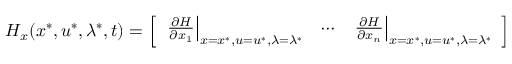<formula> <loc_0><loc_0><loc_500><loc_500>H _ { x } ( x ^ { * } , u ^ { * } , \lambda ^ { * } , t ) = { \left [ \begin{array} { l l l } { { \frac { \partial H } { \partial x _ { 1 } } } \right | _ { x = x ^ { * } , u = u ^ { * } , \lambda = \lambda ^ { * } } } & { \cdots } & { { \frac { \partial H } { \partial x _ { n } } } \right | _ { x = x ^ { * } , u = u ^ { * } , \lambda = \lambda ^ { * } } } \end{array} \right ] }</formula> 